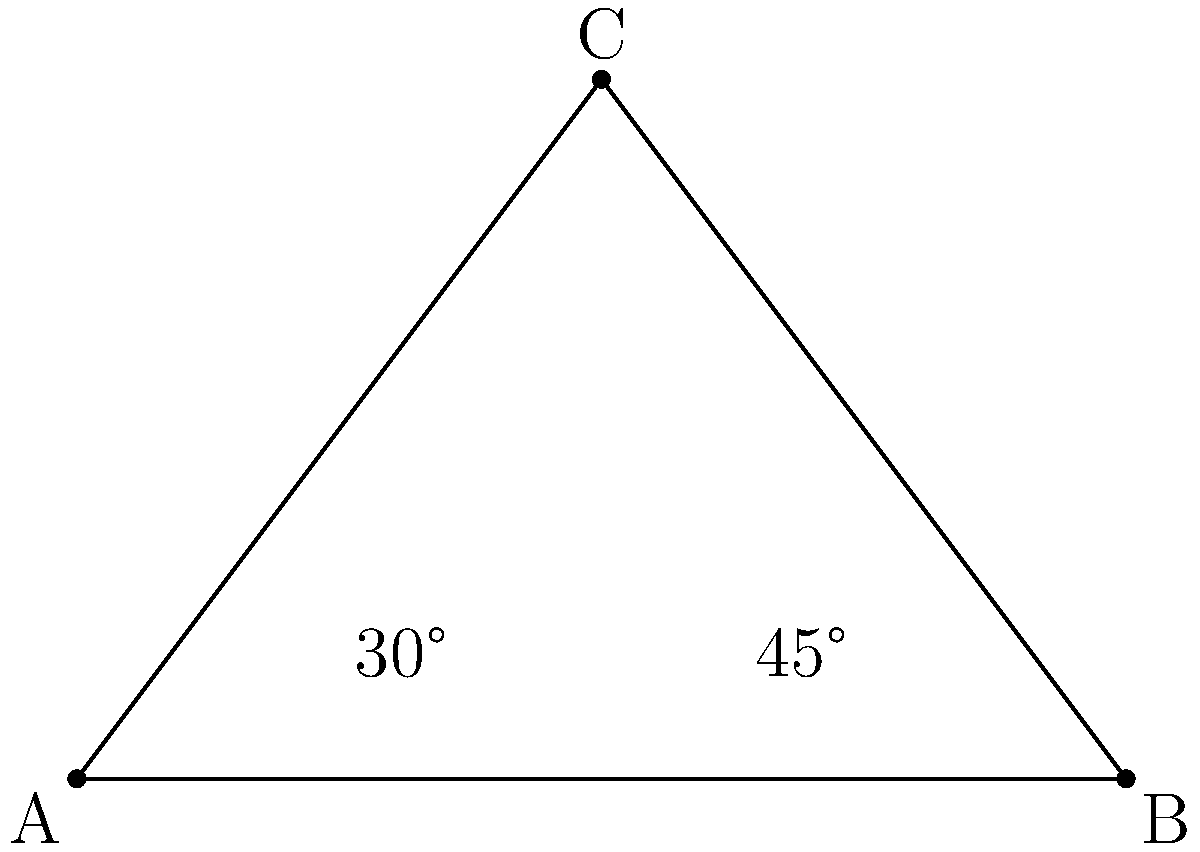A triangular bike parking structure is designed with viewing angles of 30° and 45° from two corners of a mixed-use development site. If the distance between these corners (AB) is 60 meters, what is the height (h) of the bike parking structure (point C)? Let's approach this step-by-step:

1) In the triangle ABC, we know:
   - The length of AB is 60 meters
   - The angle at A is 30°
   - The angle at B is 45°

2) We can find the angle at C using the fact that the sum of angles in a triangle is 180°:
   $180° - (30° + 45°) = 105°$

3) We can use the sine law to find the height (h):

   $\frac{\sin 30°}{60} = \frac{\sin 105°}{h}$

4) Rearranging this equation:

   $h = \frac{60 \sin 105°}{\sin 30°}$

5) We know that $\sin 30° = \frac{1}{2}$, so:

   $h = 60 \cdot 2 \sin 105°$

6) $\sin 105° = \sin (90° + 15°) = \cos 15° = \frac{\sqrt{6} + \sqrt{2}}{4}$

7) Substituting this in:

   $h = 60 \cdot 2 \cdot \frac{\sqrt{6} + \sqrt{2}}{4} = 30(\sqrt{6} + \sqrt{2})$

8) This simplifies to approximately 39.1 meters.
Answer: $30(\sqrt{6} + \sqrt{2})$ meters 